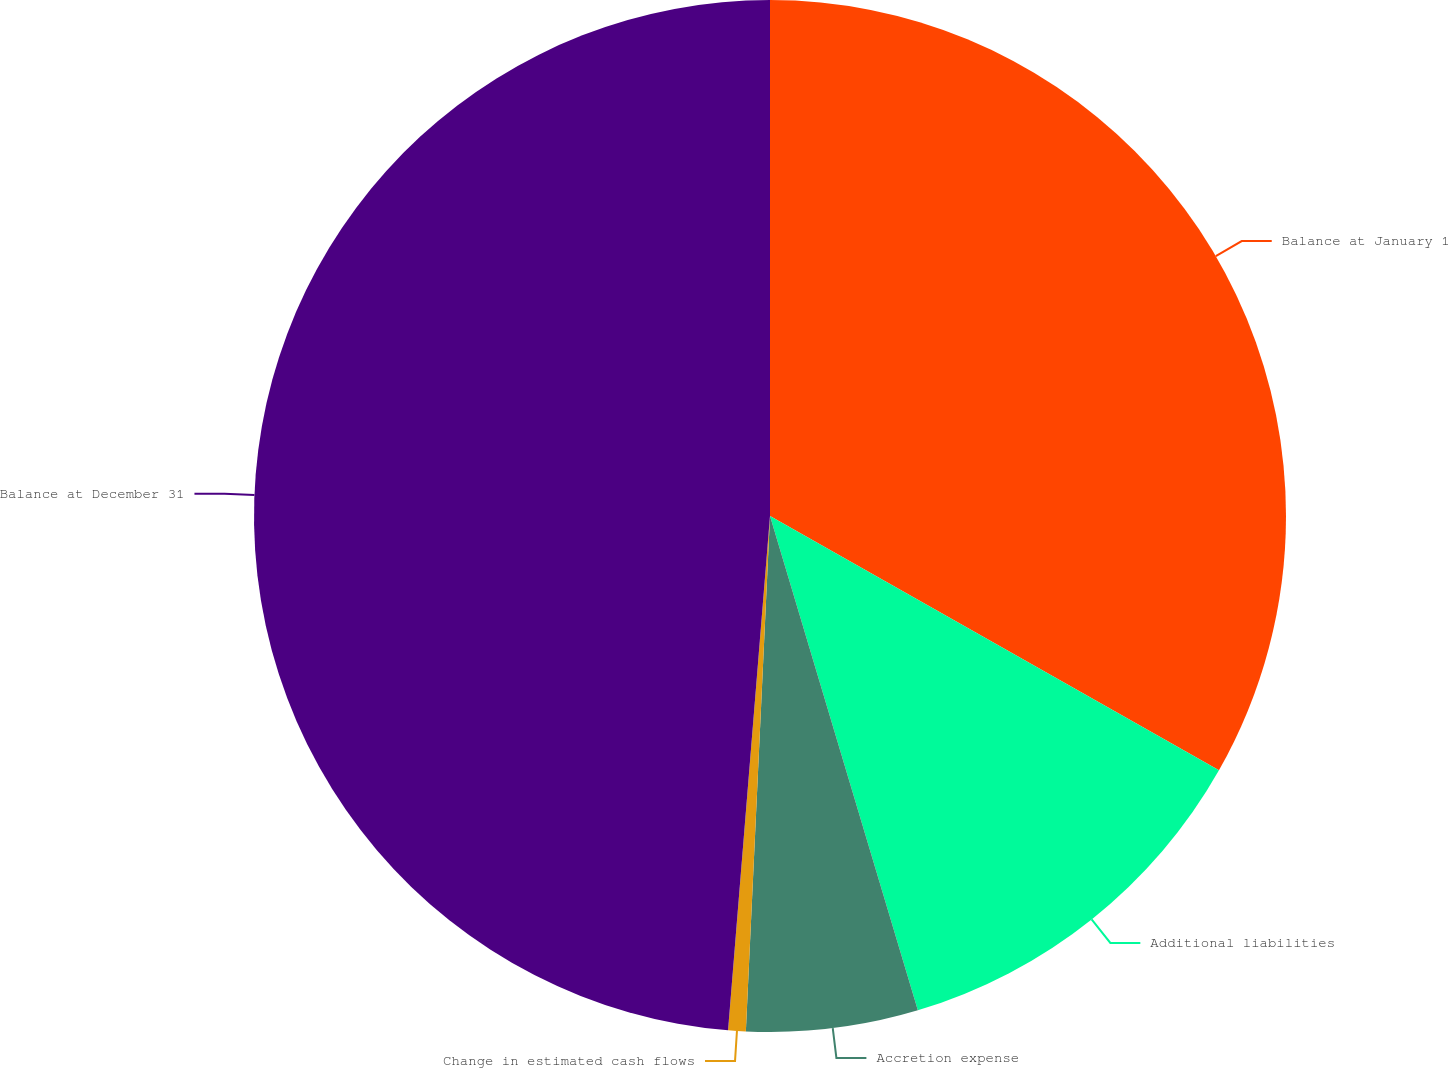<chart> <loc_0><loc_0><loc_500><loc_500><pie_chart><fcel>Balance at January 1<fcel>Additional liabilities<fcel>Accretion expense<fcel>Change in estimated cash flows<fcel>Balance at December 31<nl><fcel>33.2%<fcel>12.17%<fcel>5.37%<fcel>0.55%<fcel>48.7%<nl></chart> 